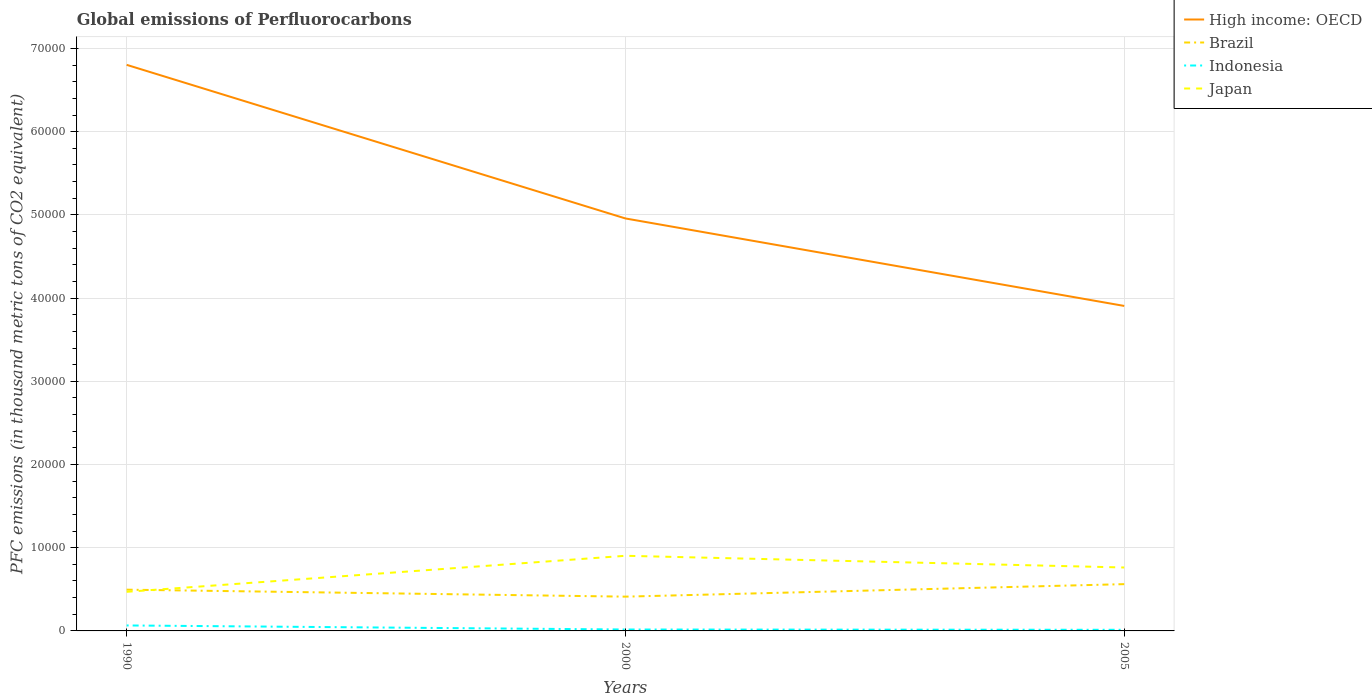How many different coloured lines are there?
Keep it short and to the point. 4. Does the line corresponding to Indonesia intersect with the line corresponding to High income: OECD?
Keep it short and to the point. No. Is the number of lines equal to the number of legend labels?
Give a very brief answer. Yes. Across all years, what is the maximum global emissions of Perfluorocarbons in Japan?
Provide a succinct answer. 4700. What is the total global emissions of Perfluorocarbons in High income: OECD in the graph?
Provide a short and direct response. 1.85e+04. What is the difference between the highest and the second highest global emissions of Perfluorocarbons in Japan?
Make the answer very short. 4329.8. How many lines are there?
Offer a terse response. 4. Does the graph contain grids?
Keep it short and to the point. Yes. How many legend labels are there?
Ensure brevity in your answer.  4. What is the title of the graph?
Your answer should be very brief. Global emissions of Perfluorocarbons. What is the label or title of the Y-axis?
Make the answer very short. PFC emissions (in thousand metric tons of CO2 equivalent). What is the PFC emissions (in thousand metric tons of CO2 equivalent) of High income: OECD in 1990?
Your answer should be compact. 6.80e+04. What is the PFC emissions (in thousand metric tons of CO2 equivalent) in Brazil in 1990?
Give a very brief answer. 4958.1. What is the PFC emissions (in thousand metric tons of CO2 equivalent) of Indonesia in 1990?
Keep it short and to the point. 657.9. What is the PFC emissions (in thousand metric tons of CO2 equivalent) in Japan in 1990?
Provide a short and direct response. 4700. What is the PFC emissions (in thousand metric tons of CO2 equivalent) of High income: OECD in 2000?
Your answer should be very brief. 4.96e+04. What is the PFC emissions (in thousand metric tons of CO2 equivalent) of Brazil in 2000?
Offer a terse response. 4119.1. What is the PFC emissions (in thousand metric tons of CO2 equivalent) of Indonesia in 2000?
Your answer should be very brief. 170.6. What is the PFC emissions (in thousand metric tons of CO2 equivalent) in Japan in 2000?
Provide a succinct answer. 9029.8. What is the PFC emissions (in thousand metric tons of CO2 equivalent) in High income: OECD in 2005?
Your answer should be very brief. 3.91e+04. What is the PFC emissions (in thousand metric tons of CO2 equivalent) in Brazil in 2005?
Your answer should be very brief. 5622.1. What is the PFC emissions (in thousand metric tons of CO2 equivalent) of Indonesia in 2005?
Ensure brevity in your answer.  134.4. What is the PFC emissions (in thousand metric tons of CO2 equivalent) of Japan in 2005?
Make the answer very short. 7623.6. Across all years, what is the maximum PFC emissions (in thousand metric tons of CO2 equivalent) in High income: OECD?
Offer a terse response. 6.80e+04. Across all years, what is the maximum PFC emissions (in thousand metric tons of CO2 equivalent) of Brazil?
Your answer should be compact. 5622.1. Across all years, what is the maximum PFC emissions (in thousand metric tons of CO2 equivalent) of Indonesia?
Provide a succinct answer. 657.9. Across all years, what is the maximum PFC emissions (in thousand metric tons of CO2 equivalent) in Japan?
Your response must be concise. 9029.8. Across all years, what is the minimum PFC emissions (in thousand metric tons of CO2 equivalent) of High income: OECD?
Offer a very short reply. 3.91e+04. Across all years, what is the minimum PFC emissions (in thousand metric tons of CO2 equivalent) of Brazil?
Give a very brief answer. 4119.1. Across all years, what is the minimum PFC emissions (in thousand metric tons of CO2 equivalent) in Indonesia?
Offer a very short reply. 134.4. Across all years, what is the minimum PFC emissions (in thousand metric tons of CO2 equivalent) of Japan?
Make the answer very short. 4700. What is the total PFC emissions (in thousand metric tons of CO2 equivalent) in High income: OECD in the graph?
Ensure brevity in your answer.  1.57e+05. What is the total PFC emissions (in thousand metric tons of CO2 equivalent) in Brazil in the graph?
Make the answer very short. 1.47e+04. What is the total PFC emissions (in thousand metric tons of CO2 equivalent) of Indonesia in the graph?
Provide a short and direct response. 962.9. What is the total PFC emissions (in thousand metric tons of CO2 equivalent) of Japan in the graph?
Keep it short and to the point. 2.14e+04. What is the difference between the PFC emissions (in thousand metric tons of CO2 equivalent) in High income: OECD in 1990 and that in 2000?
Your answer should be compact. 1.85e+04. What is the difference between the PFC emissions (in thousand metric tons of CO2 equivalent) in Brazil in 1990 and that in 2000?
Your answer should be compact. 839. What is the difference between the PFC emissions (in thousand metric tons of CO2 equivalent) in Indonesia in 1990 and that in 2000?
Make the answer very short. 487.3. What is the difference between the PFC emissions (in thousand metric tons of CO2 equivalent) in Japan in 1990 and that in 2000?
Provide a succinct answer. -4329.8. What is the difference between the PFC emissions (in thousand metric tons of CO2 equivalent) in High income: OECD in 1990 and that in 2005?
Provide a short and direct response. 2.90e+04. What is the difference between the PFC emissions (in thousand metric tons of CO2 equivalent) of Brazil in 1990 and that in 2005?
Give a very brief answer. -664. What is the difference between the PFC emissions (in thousand metric tons of CO2 equivalent) of Indonesia in 1990 and that in 2005?
Ensure brevity in your answer.  523.5. What is the difference between the PFC emissions (in thousand metric tons of CO2 equivalent) in Japan in 1990 and that in 2005?
Provide a succinct answer. -2923.6. What is the difference between the PFC emissions (in thousand metric tons of CO2 equivalent) of High income: OECD in 2000 and that in 2005?
Your answer should be very brief. 1.05e+04. What is the difference between the PFC emissions (in thousand metric tons of CO2 equivalent) of Brazil in 2000 and that in 2005?
Provide a succinct answer. -1503. What is the difference between the PFC emissions (in thousand metric tons of CO2 equivalent) in Indonesia in 2000 and that in 2005?
Provide a succinct answer. 36.2. What is the difference between the PFC emissions (in thousand metric tons of CO2 equivalent) in Japan in 2000 and that in 2005?
Keep it short and to the point. 1406.2. What is the difference between the PFC emissions (in thousand metric tons of CO2 equivalent) in High income: OECD in 1990 and the PFC emissions (in thousand metric tons of CO2 equivalent) in Brazil in 2000?
Provide a short and direct response. 6.39e+04. What is the difference between the PFC emissions (in thousand metric tons of CO2 equivalent) of High income: OECD in 1990 and the PFC emissions (in thousand metric tons of CO2 equivalent) of Indonesia in 2000?
Make the answer very short. 6.79e+04. What is the difference between the PFC emissions (in thousand metric tons of CO2 equivalent) in High income: OECD in 1990 and the PFC emissions (in thousand metric tons of CO2 equivalent) in Japan in 2000?
Your answer should be compact. 5.90e+04. What is the difference between the PFC emissions (in thousand metric tons of CO2 equivalent) of Brazil in 1990 and the PFC emissions (in thousand metric tons of CO2 equivalent) of Indonesia in 2000?
Your answer should be very brief. 4787.5. What is the difference between the PFC emissions (in thousand metric tons of CO2 equivalent) of Brazil in 1990 and the PFC emissions (in thousand metric tons of CO2 equivalent) of Japan in 2000?
Make the answer very short. -4071.7. What is the difference between the PFC emissions (in thousand metric tons of CO2 equivalent) of Indonesia in 1990 and the PFC emissions (in thousand metric tons of CO2 equivalent) of Japan in 2000?
Ensure brevity in your answer.  -8371.9. What is the difference between the PFC emissions (in thousand metric tons of CO2 equivalent) in High income: OECD in 1990 and the PFC emissions (in thousand metric tons of CO2 equivalent) in Brazil in 2005?
Make the answer very short. 6.24e+04. What is the difference between the PFC emissions (in thousand metric tons of CO2 equivalent) in High income: OECD in 1990 and the PFC emissions (in thousand metric tons of CO2 equivalent) in Indonesia in 2005?
Give a very brief answer. 6.79e+04. What is the difference between the PFC emissions (in thousand metric tons of CO2 equivalent) of High income: OECD in 1990 and the PFC emissions (in thousand metric tons of CO2 equivalent) of Japan in 2005?
Offer a very short reply. 6.04e+04. What is the difference between the PFC emissions (in thousand metric tons of CO2 equivalent) in Brazil in 1990 and the PFC emissions (in thousand metric tons of CO2 equivalent) in Indonesia in 2005?
Your response must be concise. 4823.7. What is the difference between the PFC emissions (in thousand metric tons of CO2 equivalent) in Brazil in 1990 and the PFC emissions (in thousand metric tons of CO2 equivalent) in Japan in 2005?
Ensure brevity in your answer.  -2665.5. What is the difference between the PFC emissions (in thousand metric tons of CO2 equivalent) in Indonesia in 1990 and the PFC emissions (in thousand metric tons of CO2 equivalent) in Japan in 2005?
Your response must be concise. -6965.7. What is the difference between the PFC emissions (in thousand metric tons of CO2 equivalent) in High income: OECD in 2000 and the PFC emissions (in thousand metric tons of CO2 equivalent) in Brazil in 2005?
Your answer should be compact. 4.39e+04. What is the difference between the PFC emissions (in thousand metric tons of CO2 equivalent) in High income: OECD in 2000 and the PFC emissions (in thousand metric tons of CO2 equivalent) in Indonesia in 2005?
Offer a very short reply. 4.94e+04. What is the difference between the PFC emissions (in thousand metric tons of CO2 equivalent) of High income: OECD in 2000 and the PFC emissions (in thousand metric tons of CO2 equivalent) of Japan in 2005?
Provide a succinct answer. 4.19e+04. What is the difference between the PFC emissions (in thousand metric tons of CO2 equivalent) in Brazil in 2000 and the PFC emissions (in thousand metric tons of CO2 equivalent) in Indonesia in 2005?
Keep it short and to the point. 3984.7. What is the difference between the PFC emissions (in thousand metric tons of CO2 equivalent) of Brazil in 2000 and the PFC emissions (in thousand metric tons of CO2 equivalent) of Japan in 2005?
Make the answer very short. -3504.5. What is the difference between the PFC emissions (in thousand metric tons of CO2 equivalent) in Indonesia in 2000 and the PFC emissions (in thousand metric tons of CO2 equivalent) in Japan in 2005?
Offer a terse response. -7453. What is the average PFC emissions (in thousand metric tons of CO2 equivalent) in High income: OECD per year?
Offer a terse response. 5.22e+04. What is the average PFC emissions (in thousand metric tons of CO2 equivalent) in Brazil per year?
Provide a succinct answer. 4899.77. What is the average PFC emissions (in thousand metric tons of CO2 equivalent) in Indonesia per year?
Provide a succinct answer. 320.97. What is the average PFC emissions (in thousand metric tons of CO2 equivalent) of Japan per year?
Keep it short and to the point. 7117.8. In the year 1990, what is the difference between the PFC emissions (in thousand metric tons of CO2 equivalent) in High income: OECD and PFC emissions (in thousand metric tons of CO2 equivalent) in Brazil?
Give a very brief answer. 6.31e+04. In the year 1990, what is the difference between the PFC emissions (in thousand metric tons of CO2 equivalent) in High income: OECD and PFC emissions (in thousand metric tons of CO2 equivalent) in Indonesia?
Give a very brief answer. 6.74e+04. In the year 1990, what is the difference between the PFC emissions (in thousand metric tons of CO2 equivalent) of High income: OECD and PFC emissions (in thousand metric tons of CO2 equivalent) of Japan?
Give a very brief answer. 6.33e+04. In the year 1990, what is the difference between the PFC emissions (in thousand metric tons of CO2 equivalent) of Brazil and PFC emissions (in thousand metric tons of CO2 equivalent) of Indonesia?
Your answer should be very brief. 4300.2. In the year 1990, what is the difference between the PFC emissions (in thousand metric tons of CO2 equivalent) in Brazil and PFC emissions (in thousand metric tons of CO2 equivalent) in Japan?
Provide a short and direct response. 258.1. In the year 1990, what is the difference between the PFC emissions (in thousand metric tons of CO2 equivalent) of Indonesia and PFC emissions (in thousand metric tons of CO2 equivalent) of Japan?
Provide a succinct answer. -4042.1. In the year 2000, what is the difference between the PFC emissions (in thousand metric tons of CO2 equivalent) in High income: OECD and PFC emissions (in thousand metric tons of CO2 equivalent) in Brazil?
Offer a very short reply. 4.55e+04. In the year 2000, what is the difference between the PFC emissions (in thousand metric tons of CO2 equivalent) of High income: OECD and PFC emissions (in thousand metric tons of CO2 equivalent) of Indonesia?
Make the answer very short. 4.94e+04. In the year 2000, what is the difference between the PFC emissions (in thousand metric tons of CO2 equivalent) in High income: OECD and PFC emissions (in thousand metric tons of CO2 equivalent) in Japan?
Offer a very short reply. 4.05e+04. In the year 2000, what is the difference between the PFC emissions (in thousand metric tons of CO2 equivalent) of Brazil and PFC emissions (in thousand metric tons of CO2 equivalent) of Indonesia?
Provide a succinct answer. 3948.5. In the year 2000, what is the difference between the PFC emissions (in thousand metric tons of CO2 equivalent) in Brazil and PFC emissions (in thousand metric tons of CO2 equivalent) in Japan?
Your response must be concise. -4910.7. In the year 2000, what is the difference between the PFC emissions (in thousand metric tons of CO2 equivalent) of Indonesia and PFC emissions (in thousand metric tons of CO2 equivalent) of Japan?
Provide a succinct answer. -8859.2. In the year 2005, what is the difference between the PFC emissions (in thousand metric tons of CO2 equivalent) in High income: OECD and PFC emissions (in thousand metric tons of CO2 equivalent) in Brazil?
Offer a very short reply. 3.34e+04. In the year 2005, what is the difference between the PFC emissions (in thousand metric tons of CO2 equivalent) in High income: OECD and PFC emissions (in thousand metric tons of CO2 equivalent) in Indonesia?
Your response must be concise. 3.89e+04. In the year 2005, what is the difference between the PFC emissions (in thousand metric tons of CO2 equivalent) of High income: OECD and PFC emissions (in thousand metric tons of CO2 equivalent) of Japan?
Provide a succinct answer. 3.14e+04. In the year 2005, what is the difference between the PFC emissions (in thousand metric tons of CO2 equivalent) in Brazil and PFC emissions (in thousand metric tons of CO2 equivalent) in Indonesia?
Give a very brief answer. 5487.7. In the year 2005, what is the difference between the PFC emissions (in thousand metric tons of CO2 equivalent) of Brazil and PFC emissions (in thousand metric tons of CO2 equivalent) of Japan?
Make the answer very short. -2001.5. In the year 2005, what is the difference between the PFC emissions (in thousand metric tons of CO2 equivalent) of Indonesia and PFC emissions (in thousand metric tons of CO2 equivalent) of Japan?
Provide a succinct answer. -7489.2. What is the ratio of the PFC emissions (in thousand metric tons of CO2 equivalent) in High income: OECD in 1990 to that in 2000?
Your answer should be very brief. 1.37. What is the ratio of the PFC emissions (in thousand metric tons of CO2 equivalent) in Brazil in 1990 to that in 2000?
Your answer should be compact. 1.2. What is the ratio of the PFC emissions (in thousand metric tons of CO2 equivalent) of Indonesia in 1990 to that in 2000?
Offer a very short reply. 3.86. What is the ratio of the PFC emissions (in thousand metric tons of CO2 equivalent) of Japan in 1990 to that in 2000?
Offer a very short reply. 0.52. What is the ratio of the PFC emissions (in thousand metric tons of CO2 equivalent) of High income: OECD in 1990 to that in 2005?
Offer a terse response. 1.74. What is the ratio of the PFC emissions (in thousand metric tons of CO2 equivalent) of Brazil in 1990 to that in 2005?
Your answer should be very brief. 0.88. What is the ratio of the PFC emissions (in thousand metric tons of CO2 equivalent) of Indonesia in 1990 to that in 2005?
Ensure brevity in your answer.  4.9. What is the ratio of the PFC emissions (in thousand metric tons of CO2 equivalent) in Japan in 1990 to that in 2005?
Ensure brevity in your answer.  0.62. What is the ratio of the PFC emissions (in thousand metric tons of CO2 equivalent) in High income: OECD in 2000 to that in 2005?
Provide a short and direct response. 1.27. What is the ratio of the PFC emissions (in thousand metric tons of CO2 equivalent) of Brazil in 2000 to that in 2005?
Ensure brevity in your answer.  0.73. What is the ratio of the PFC emissions (in thousand metric tons of CO2 equivalent) of Indonesia in 2000 to that in 2005?
Ensure brevity in your answer.  1.27. What is the ratio of the PFC emissions (in thousand metric tons of CO2 equivalent) in Japan in 2000 to that in 2005?
Give a very brief answer. 1.18. What is the difference between the highest and the second highest PFC emissions (in thousand metric tons of CO2 equivalent) in High income: OECD?
Make the answer very short. 1.85e+04. What is the difference between the highest and the second highest PFC emissions (in thousand metric tons of CO2 equivalent) of Brazil?
Provide a short and direct response. 664. What is the difference between the highest and the second highest PFC emissions (in thousand metric tons of CO2 equivalent) of Indonesia?
Offer a terse response. 487.3. What is the difference between the highest and the second highest PFC emissions (in thousand metric tons of CO2 equivalent) of Japan?
Your answer should be very brief. 1406.2. What is the difference between the highest and the lowest PFC emissions (in thousand metric tons of CO2 equivalent) of High income: OECD?
Give a very brief answer. 2.90e+04. What is the difference between the highest and the lowest PFC emissions (in thousand metric tons of CO2 equivalent) of Brazil?
Your answer should be compact. 1503. What is the difference between the highest and the lowest PFC emissions (in thousand metric tons of CO2 equivalent) in Indonesia?
Provide a succinct answer. 523.5. What is the difference between the highest and the lowest PFC emissions (in thousand metric tons of CO2 equivalent) of Japan?
Ensure brevity in your answer.  4329.8. 